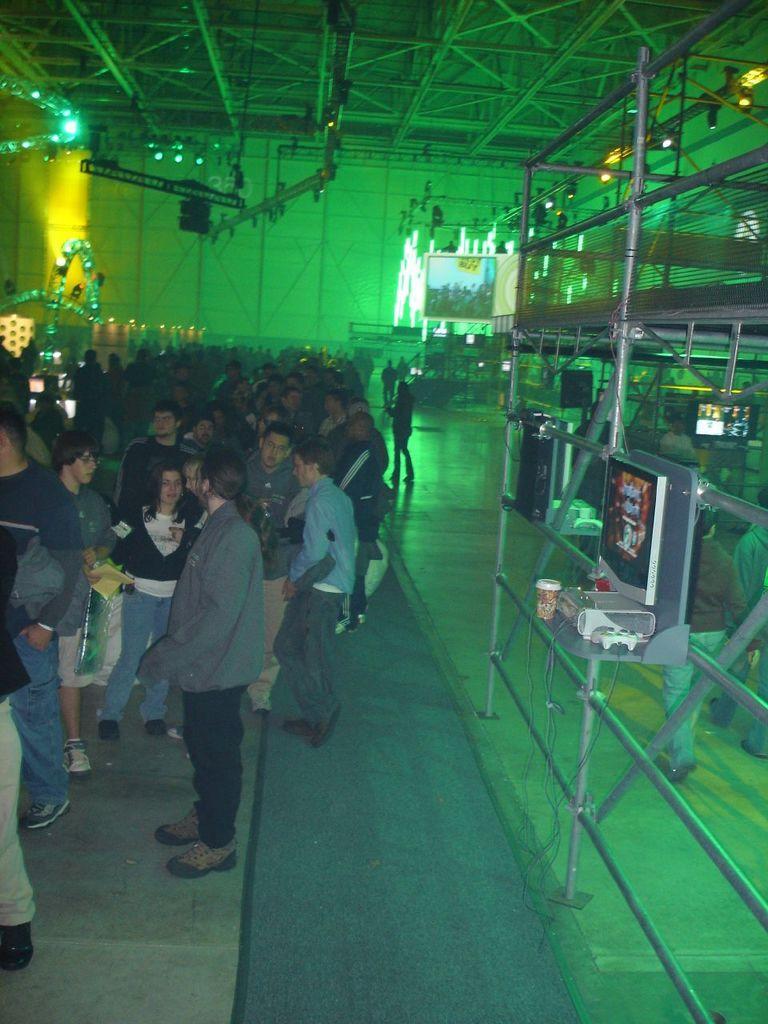How would you summarize this image in a sentence or two? In the foreground of this image, on the left, there are people standing and walking on the floor. On the right, there is a pole structure, a screen, an electronic device, a glass and a remote. In the background, there is green light, screen, few lights and the inside roof of a shelter. 